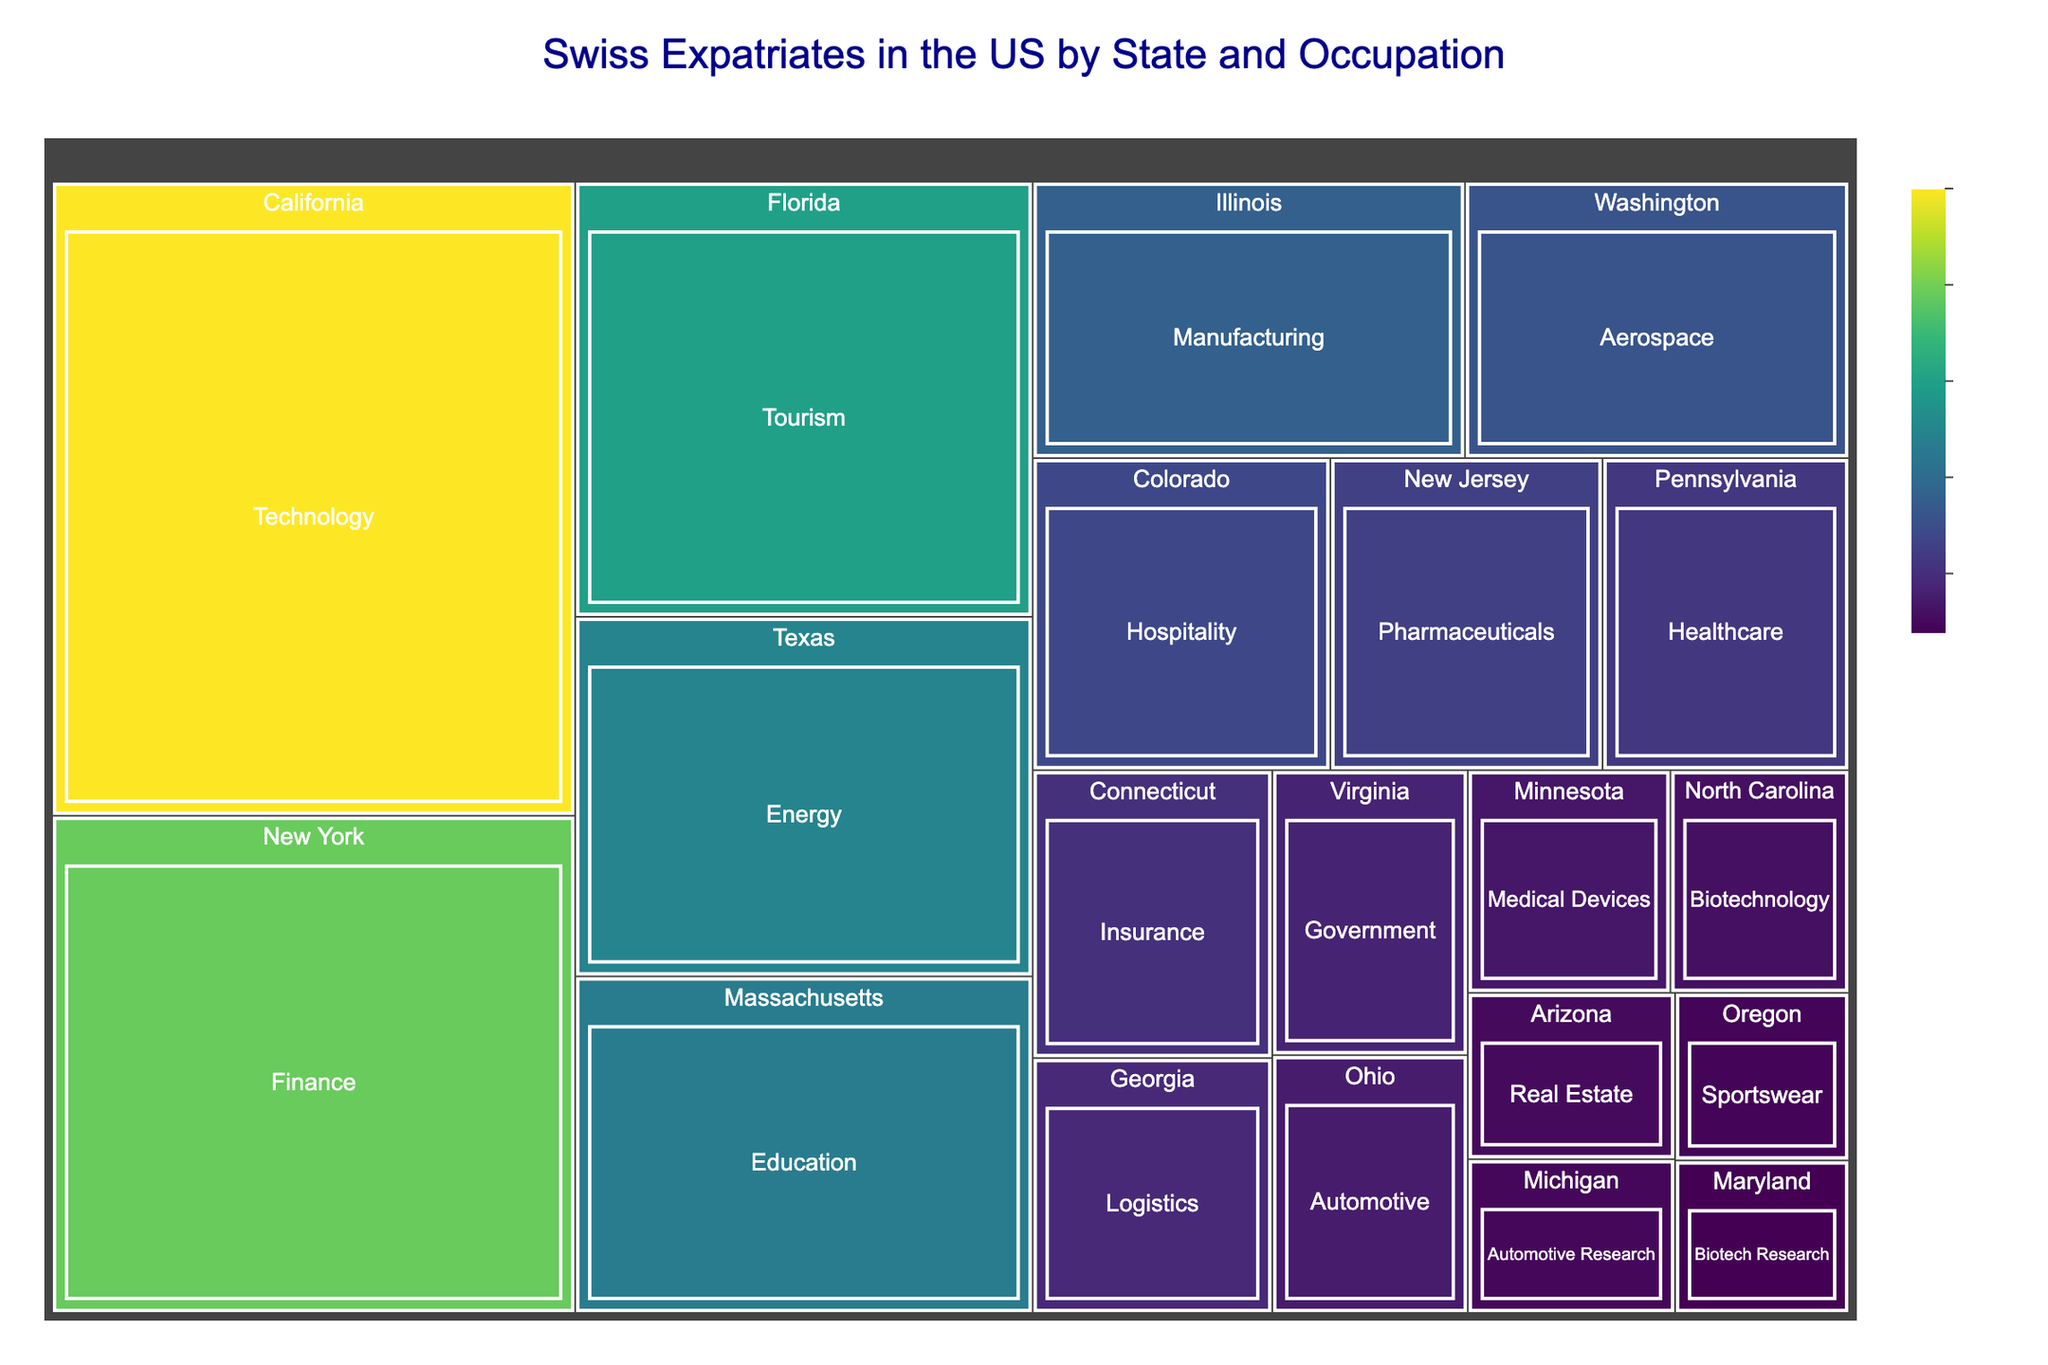What is the title of the treemap? The title of the treemap can be found at the top center of the figure, formatted with a larger font size and different color.
Answer: Swiss Expatriates in the US by State and Occupation Which state has the highest number of Swiss expatriates in the Technology sector? The state with the largest area and highest color intensity for the Technology sector can be identified.
Answer: California What's the total number of Swiss expatriates in the Healthcare and Education sectors combined? Sum the counts from the Healthcare sector in Pennsylvania and the Education sector in Massachusetts: 290 + 580.
Answer: 870 Which sector has the smallest number of expatriates and in which state is it located? The smallest section with the lowest color intensity and area corresponds to this sector and state combination.
Answer: Biotech Research in Maryland How does the number of Swiss expatriates in the Finance sector of New York compare to those in the Hospitality sector of Colorado? Compare the counts directly from the Finance sector in New York (980) to the Hospitality sector in Colorado (350).
Answer: New York has 630 more expatriates in the Finance sector What is the median number of expatriates across all states mentioned? List all counts, arrange them in ascending order, and find the middle value(s): [100, 110, 120, 130, 150, 170, 190, 210, 230, 260, 290, 320, 350, 400, 450, 580, 620, 750, 980, 1250]. With 20 data points, the median is the average of the 10th and 11th values: (260+290)/2.
Answer: 275 Which occupation sector in Texas and Massachusetts combined has a higher count, and what is the difference? Compare the counts: Texas's Energy sector (620) and Massachusetts's Education sector (580). Calculate the difference: 620 - 580.
Answer: Texas's Energy sector has 40 more expatriates How does the count of expatriates in the Logistics sector in Georgia compare to the Automotive Research sector in Michigan? Directly compare the counts from Georgia (230) and Michigan (120).
Answer: Georgia has 110 more expatriates in the Logistics sector What percentage of the total expatriates does the Technology sector in California represent? Sum all counts to find the total number of expatriates (7610). Divide the Technology sector count (1250) by the total and multiply by 100: (1250 / 7610) * 100.
Answer: Approximately 16.42% Which state and sector has the closest count to the Healthcare sector in Pennsylvania? Compare Pennsylvania's Healthcare sector count (290) with other counts, and find the closest value.
Answer: New Jersey's Pharmaceutical sector (320), with a difference of 30 